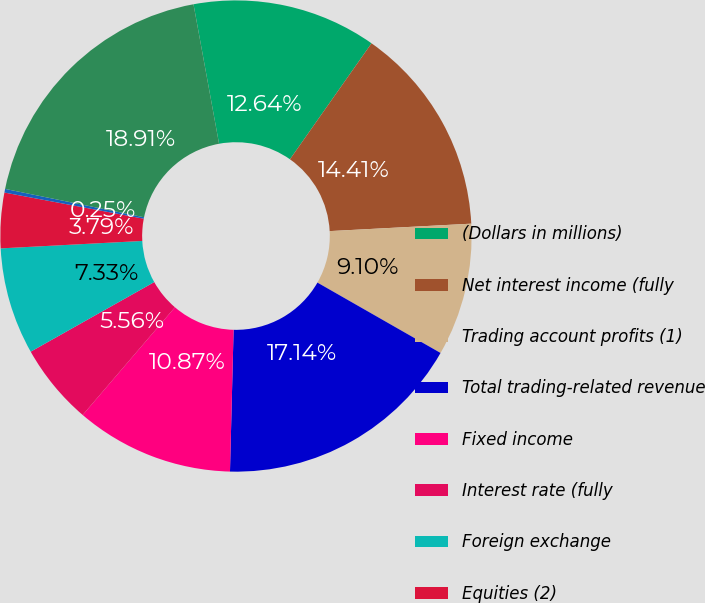Convert chart to OTSL. <chart><loc_0><loc_0><loc_500><loc_500><pie_chart><fcel>(Dollars in millions)<fcel>Net interest income (fully<fcel>Trading account profits (1)<fcel>Total trading-related revenue<fcel>Fixed income<fcel>Interest rate (fully<fcel>Foreign exchange<fcel>Equities (2)<fcel>Commodities<fcel>Market-based trading-related<nl><fcel>12.64%<fcel>14.41%<fcel>9.1%<fcel>17.14%<fcel>10.87%<fcel>5.56%<fcel>7.33%<fcel>3.79%<fcel>0.25%<fcel>18.91%<nl></chart> 